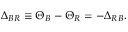Convert formula to latex. <formula><loc_0><loc_0><loc_500><loc_500>\Delta _ { B R } \equiv \Theta _ { B } - \Theta _ { R } = - \Delta _ { R B } .</formula> 